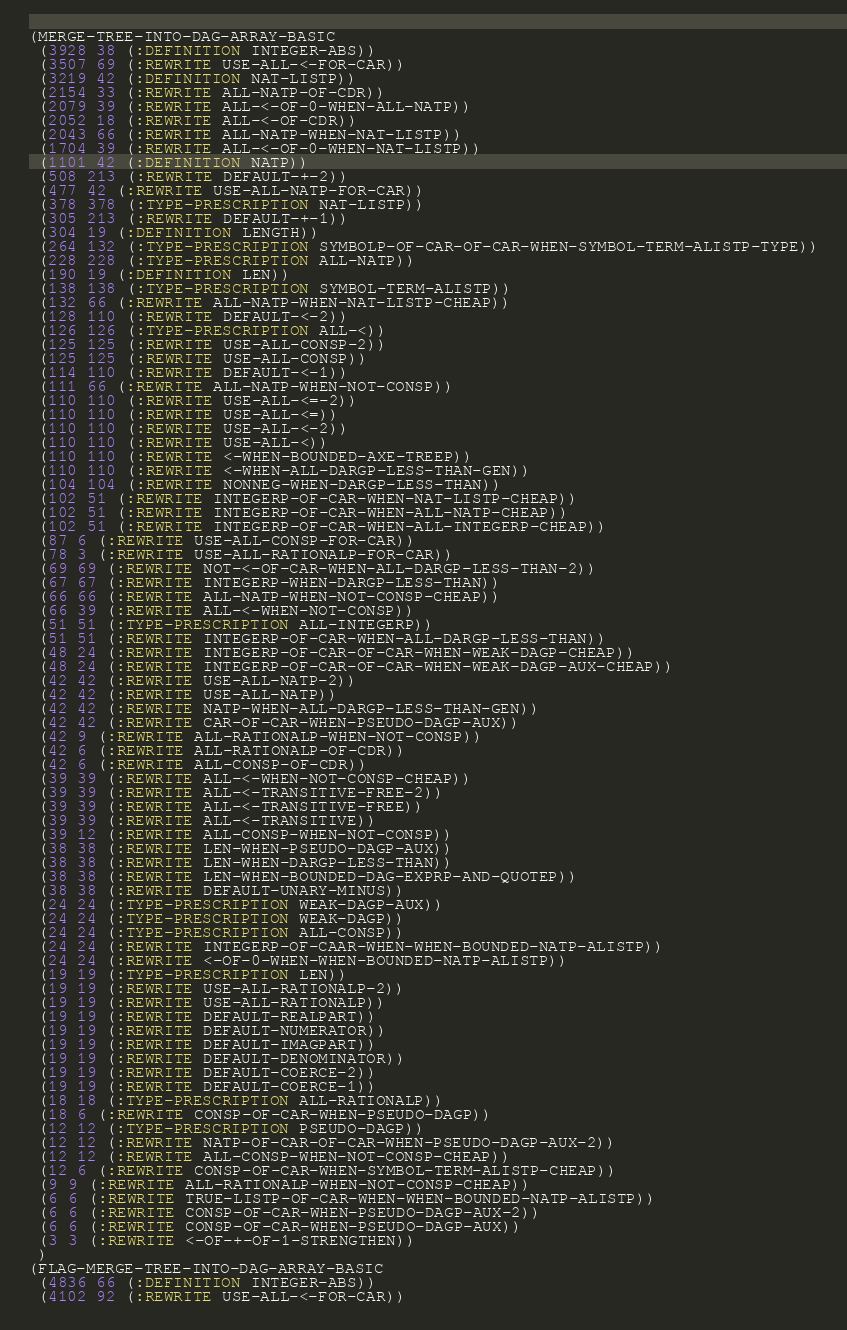<code> <loc_0><loc_0><loc_500><loc_500><_Lisp_>(MERGE-TREE-INTO-DAG-ARRAY-BASIC
 (3928 38 (:DEFINITION INTEGER-ABS))
 (3507 69 (:REWRITE USE-ALL-<-FOR-CAR))
 (3219 42 (:DEFINITION NAT-LISTP))
 (2154 33 (:REWRITE ALL-NATP-OF-CDR))
 (2079 39 (:REWRITE ALL-<-OF-0-WHEN-ALL-NATP))
 (2052 18 (:REWRITE ALL-<-OF-CDR))
 (2043 66 (:REWRITE ALL-NATP-WHEN-NAT-LISTP))
 (1704 39 (:REWRITE ALL-<-OF-0-WHEN-NAT-LISTP))
 (1101 42 (:DEFINITION NATP))
 (508 213 (:REWRITE DEFAULT-+-2))
 (477 42 (:REWRITE USE-ALL-NATP-FOR-CAR))
 (378 378 (:TYPE-PRESCRIPTION NAT-LISTP))
 (305 213 (:REWRITE DEFAULT-+-1))
 (304 19 (:DEFINITION LENGTH))
 (264 132 (:TYPE-PRESCRIPTION SYMBOLP-OF-CAR-OF-CAR-WHEN-SYMBOL-TERM-ALISTP-TYPE))
 (228 228 (:TYPE-PRESCRIPTION ALL-NATP))
 (190 19 (:DEFINITION LEN))
 (138 138 (:TYPE-PRESCRIPTION SYMBOL-TERM-ALISTP))
 (132 66 (:REWRITE ALL-NATP-WHEN-NAT-LISTP-CHEAP))
 (128 110 (:REWRITE DEFAULT-<-2))
 (126 126 (:TYPE-PRESCRIPTION ALL-<))
 (125 125 (:REWRITE USE-ALL-CONSP-2))
 (125 125 (:REWRITE USE-ALL-CONSP))
 (114 110 (:REWRITE DEFAULT-<-1))
 (111 66 (:REWRITE ALL-NATP-WHEN-NOT-CONSP))
 (110 110 (:REWRITE USE-ALL-<=-2))
 (110 110 (:REWRITE USE-ALL-<=))
 (110 110 (:REWRITE USE-ALL-<-2))
 (110 110 (:REWRITE USE-ALL-<))
 (110 110 (:REWRITE <-WHEN-BOUNDED-AXE-TREEP))
 (110 110 (:REWRITE <-WHEN-ALL-DARGP-LESS-THAN-GEN))
 (104 104 (:REWRITE NONNEG-WHEN-DARGP-LESS-THAN))
 (102 51 (:REWRITE INTEGERP-OF-CAR-WHEN-NAT-LISTP-CHEAP))
 (102 51 (:REWRITE INTEGERP-OF-CAR-WHEN-ALL-NATP-CHEAP))
 (102 51 (:REWRITE INTEGERP-OF-CAR-WHEN-ALL-INTEGERP-CHEAP))
 (87 6 (:REWRITE USE-ALL-CONSP-FOR-CAR))
 (78 3 (:REWRITE USE-ALL-RATIONALP-FOR-CAR))
 (69 69 (:REWRITE NOT-<-OF-CAR-WHEN-ALL-DARGP-LESS-THAN-2))
 (67 67 (:REWRITE INTEGERP-WHEN-DARGP-LESS-THAN))
 (66 66 (:REWRITE ALL-NATP-WHEN-NOT-CONSP-CHEAP))
 (66 39 (:REWRITE ALL-<-WHEN-NOT-CONSP))
 (51 51 (:TYPE-PRESCRIPTION ALL-INTEGERP))
 (51 51 (:REWRITE INTEGERP-OF-CAR-WHEN-ALL-DARGP-LESS-THAN))
 (48 24 (:REWRITE INTEGERP-OF-CAR-OF-CAR-WHEN-WEAK-DAGP-CHEAP))
 (48 24 (:REWRITE INTEGERP-OF-CAR-OF-CAR-WHEN-WEAK-DAGP-AUX-CHEAP))
 (42 42 (:REWRITE USE-ALL-NATP-2))
 (42 42 (:REWRITE USE-ALL-NATP))
 (42 42 (:REWRITE NATP-WHEN-ALL-DARGP-LESS-THAN-GEN))
 (42 42 (:REWRITE CAR-OF-CAR-WHEN-PSEUDO-DAGP-AUX))
 (42 9 (:REWRITE ALL-RATIONALP-WHEN-NOT-CONSP))
 (42 6 (:REWRITE ALL-RATIONALP-OF-CDR))
 (42 6 (:REWRITE ALL-CONSP-OF-CDR))
 (39 39 (:REWRITE ALL-<-WHEN-NOT-CONSP-CHEAP))
 (39 39 (:REWRITE ALL-<-TRANSITIVE-FREE-2))
 (39 39 (:REWRITE ALL-<-TRANSITIVE-FREE))
 (39 39 (:REWRITE ALL-<-TRANSITIVE))
 (39 12 (:REWRITE ALL-CONSP-WHEN-NOT-CONSP))
 (38 38 (:REWRITE LEN-WHEN-PSEUDO-DAGP-AUX))
 (38 38 (:REWRITE LEN-WHEN-DARGP-LESS-THAN))
 (38 38 (:REWRITE LEN-WHEN-BOUNDED-DAG-EXPRP-AND-QUOTEP))
 (38 38 (:REWRITE DEFAULT-UNARY-MINUS))
 (24 24 (:TYPE-PRESCRIPTION WEAK-DAGP-AUX))
 (24 24 (:TYPE-PRESCRIPTION WEAK-DAGP))
 (24 24 (:TYPE-PRESCRIPTION ALL-CONSP))
 (24 24 (:REWRITE INTEGERP-OF-CAAR-WHEN-WHEN-BOUNDED-NATP-ALISTP))
 (24 24 (:REWRITE <-OF-0-WHEN-WHEN-BOUNDED-NATP-ALISTP))
 (19 19 (:TYPE-PRESCRIPTION LEN))
 (19 19 (:REWRITE USE-ALL-RATIONALP-2))
 (19 19 (:REWRITE USE-ALL-RATIONALP))
 (19 19 (:REWRITE DEFAULT-REALPART))
 (19 19 (:REWRITE DEFAULT-NUMERATOR))
 (19 19 (:REWRITE DEFAULT-IMAGPART))
 (19 19 (:REWRITE DEFAULT-DENOMINATOR))
 (19 19 (:REWRITE DEFAULT-COERCE-2))
 (19 19 (:REWRITE DEFAULT-COERCE-1))
 (18 18 (:TYPE-PRESCRIPTION ALL-RATIONALP))
 (18 6 (:REWRITE CONSP-OF-CAR-WHEN-PSEUDO-DAGP))
 (12 12 (:TYPE-PRESCRIPTION PSEUDO-DAGP))
 (12 12 (:REWRITE NATP-OF-CAR-OF-CAR-WHEN-PSEUDO-DAGP-AUX-2))
 (12 12 (:REWRITE ALL-CONSP-WHEN-NOT-CONSP-CHEAP))
 (12 6 (:REWRITE CONSP-OF-CAR-WHEN-SYMBOL-TERM-ALISTP-CHEAP))
 (9 9 (:REWRITE ALL-RATIONALP-WHEN-NOT-CONSP-CHEAP))
 (6 6 (:REWRITE TRUE-LISTP-OF-CAR-WHEN-WHEN-BOUNDED-NATP-ALISTP))
 (6 6 (:REWRITE CONSP-OF-CAR-WHEN-PSEUDO-DAGP-AUX-2))
 (6 6 (:REWRITE CONSP-OF-CAR-WHEN-PSEUDO-DAGP-AUX))
 (3 3 (:REWRITE <-OF-+-OF-1-STRENGTHEN))
 )
(FLAG-MERGE-TREE-INTO-DAG-ARRAY-BASIC
 (4836 66 (:DEFINITION INTEGER-ABS))
 (4102 92 (:REWRITE USE-ALL-<-FOR-CAR))</code> 